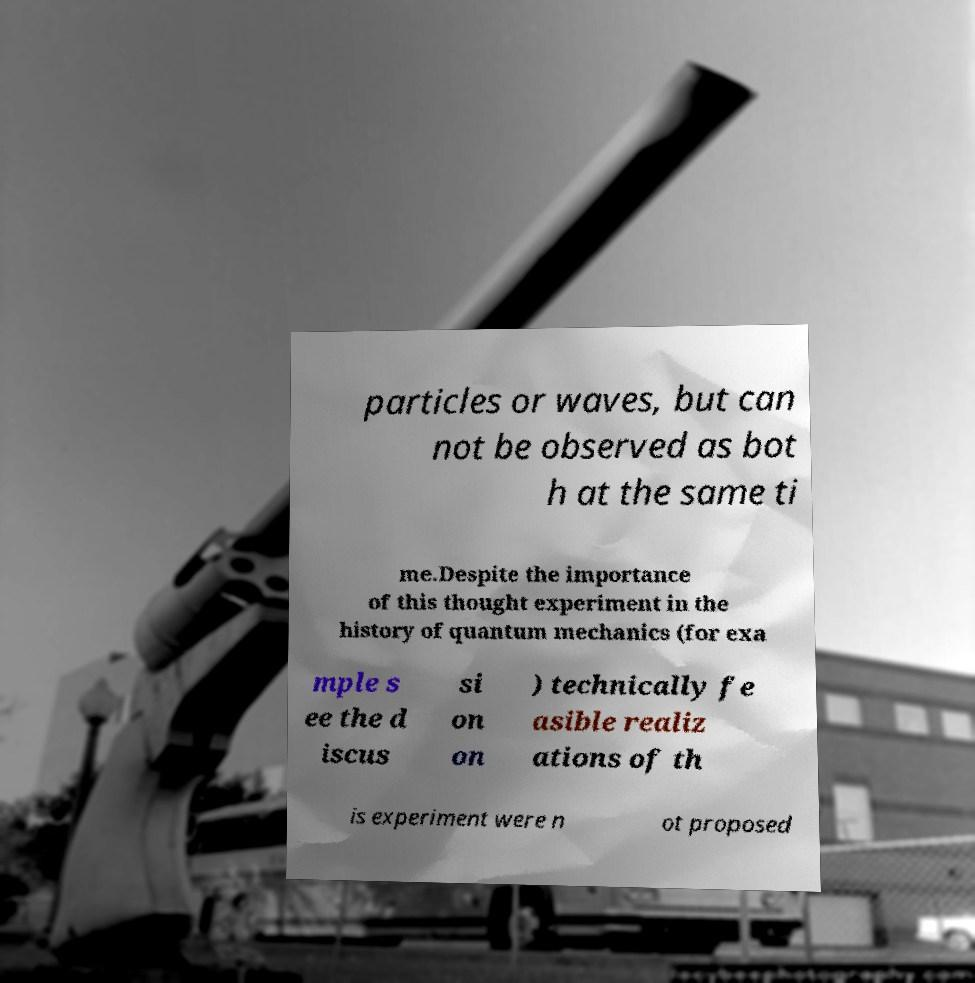I need the written content from this picture converted into text. Can you do that? particles or waves, but can not be observed as bot h at the same ti me.Despite the importance of this thought experiment in the history of quantum mechanics (for exa mple s ee the d iscus si on on ) technically fe asible realiz ations of th is experiment were n ot proposed 